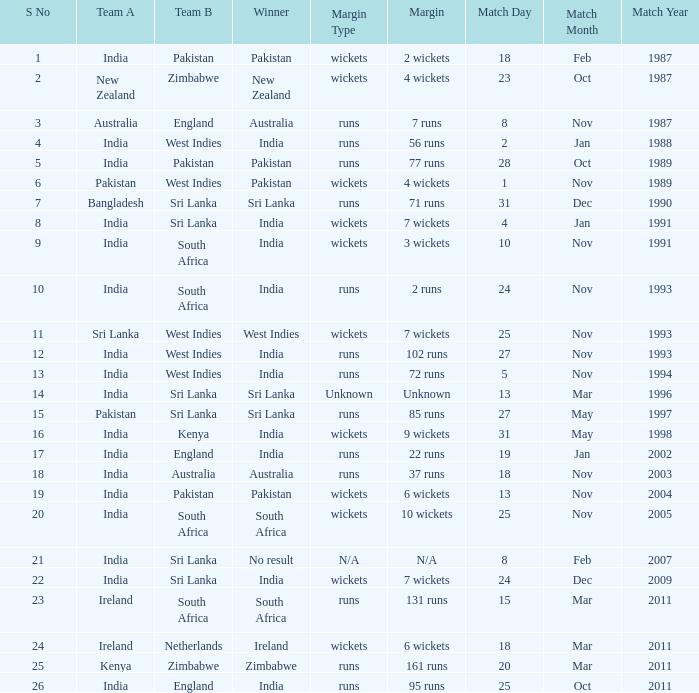Who won the match when the margin was 131 runs? South Africa. 